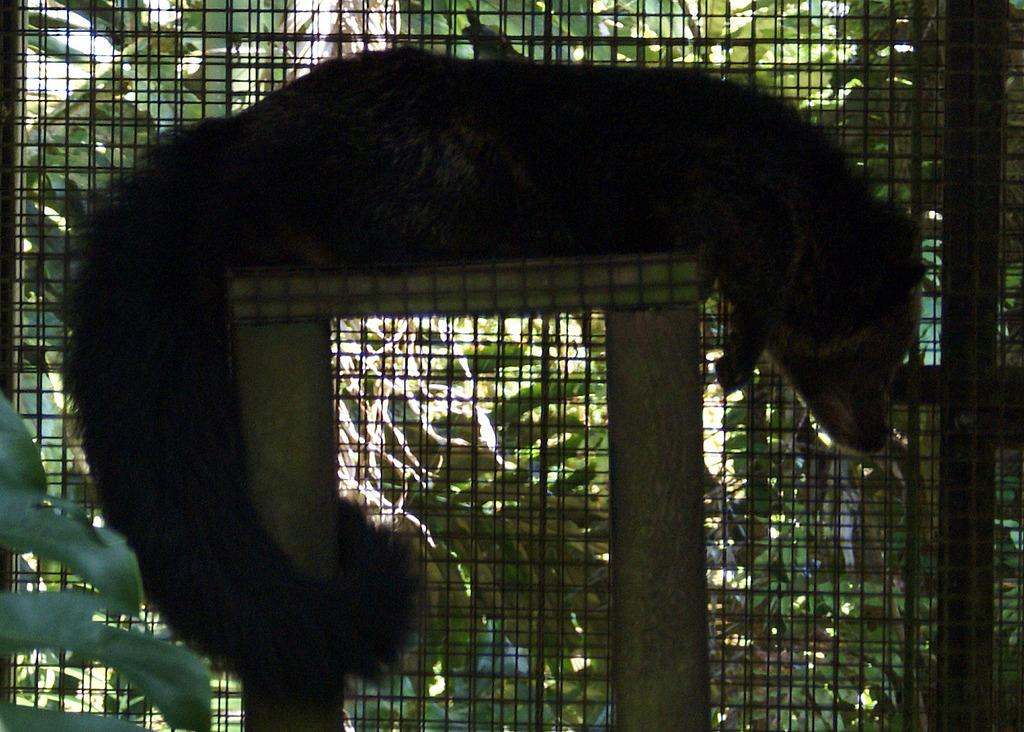What type of creature is in the picture? There is an animal in the picture. What is the animal doing in the image? The animal is lying on a stool. What is behind the animal in the image? There is a mesh behind the animal. What can be seen beyond the mesh in the image? There are plants behind the mesh. What type of account does the animal have with the bank in the image? There is no indication of an account or any financial activity in the image; it features an animal lying on a stool with a mesh and plants in the background. 